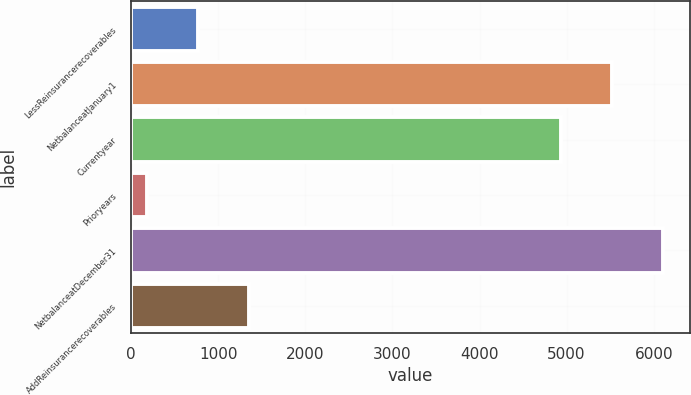Convert chart. <chart><loc_0><loc_0><loc_500><loc_500><bar_chart><fcel>LessReinsurancerecoverables<fcel>NetbalanceatJanuary1<fcel>Currentyear<fcel>Prioryears<fcel>NetbalanceatDecember31<fcel>AddReinsurancerecoverables<nl><fcel>765.7<fcel>5525.7<fcel>4940<fcel>180<fcel>6111.4<fcel>1351.4<nl></chart> 